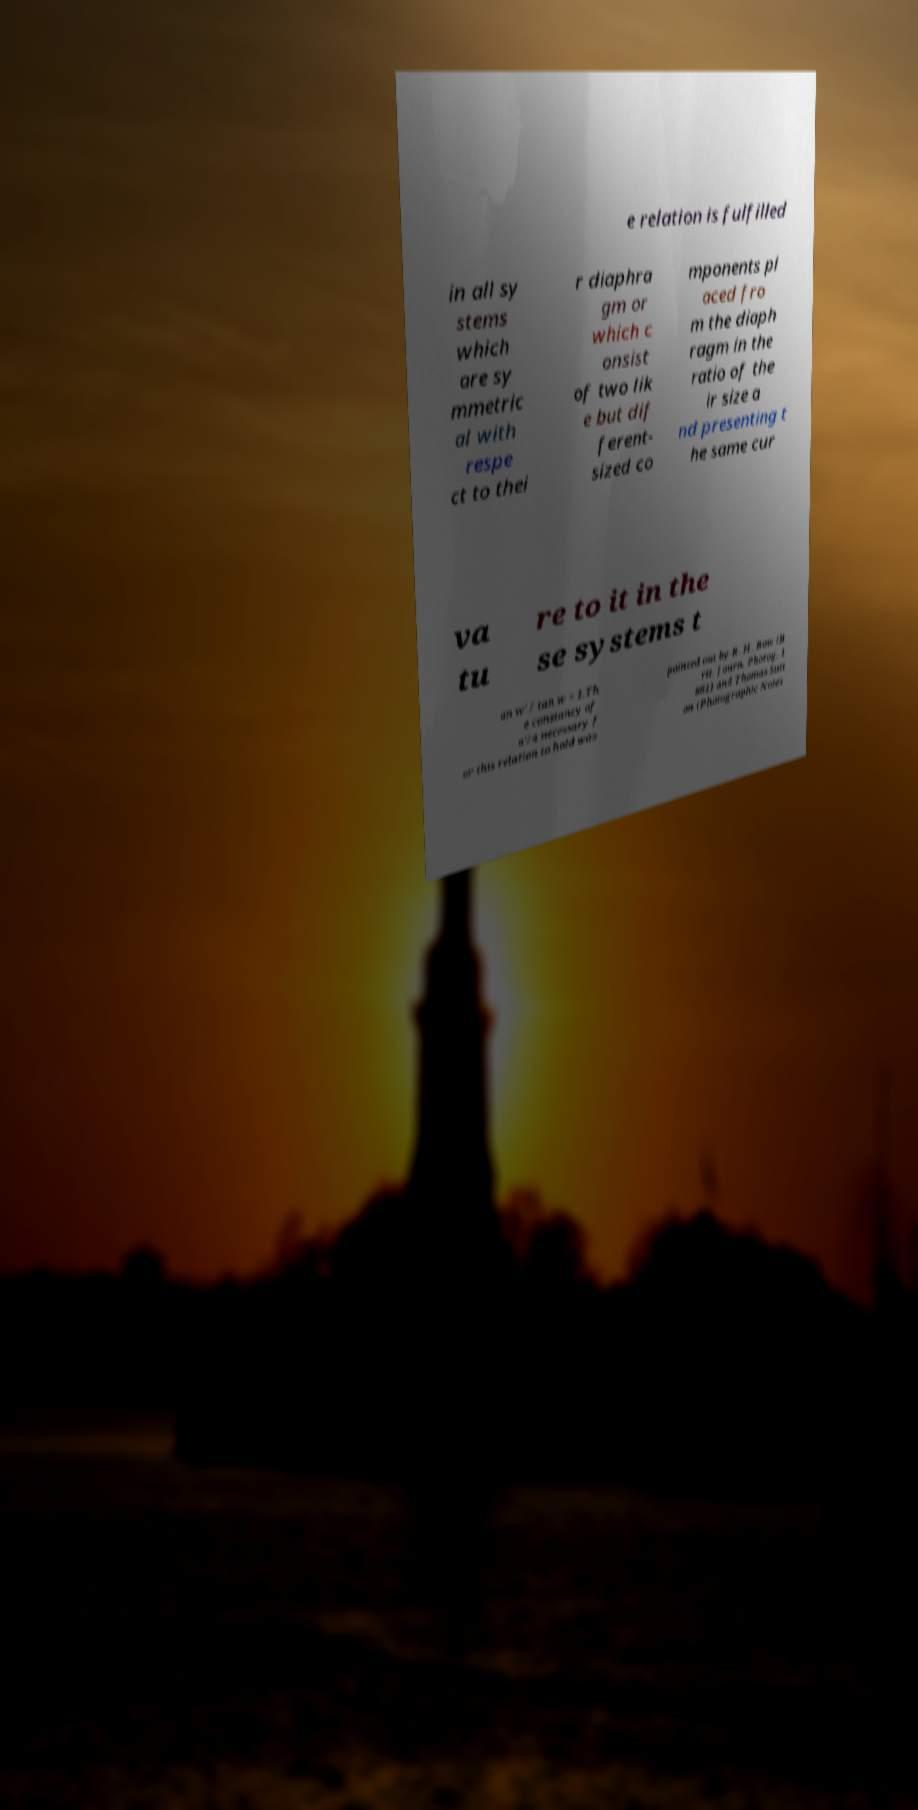I need the written content from this picture converted into text. Can you do that? e relation is fulfilled in all sy stems which are sy mmetric al with respe ct to thei r diaphra gm or which c onsist of two lik e but dif ferent- sized co mponents pl aced fro m the diaph ragm in the ratio of the ir size a nd presenting t he same cur va tu re to it in the se systems t an w' / tan w = 1.Th e constancy of a'/a necessary f or this relation to hold was pointed out by R. H. Bow (B rit. Journ. Photog. 1 861) and Thomas Sutt on (Photographic Notes 